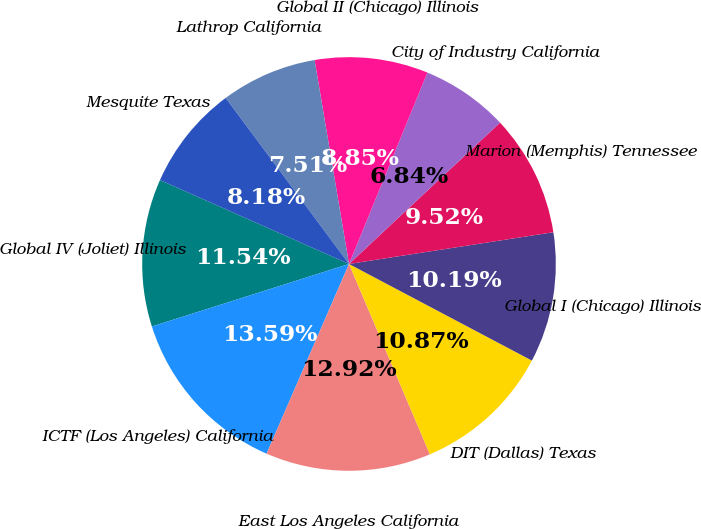Convert chart to OTSL. <chart><loc_0><loc_0><loc_500><loc_500><pie_chart><fcel>Global IV (Joliet) Illinois<fcel>ICTF (Los Angeles) California<fcel>East Los Angeles California<fcel>DIT (Dallas) Texas<fcel>Global I (Chicago) Illinois<fcel>Marion (Memphis) Tennessee<fcel>City of Industry California<fcel>Global II (Chicago) Illinois<fcel>Lathrop California<fcel>Mesquite Texas<nl><fcel>11.54%<fcel>13.59%<fcel>12.92%<fcel>10.87%<fcel>10.19%<fcel>9.52%<fcel>6.84%<fcel>8.85%<fcel>7.51%<fcel>8.18%<nl></chart> 